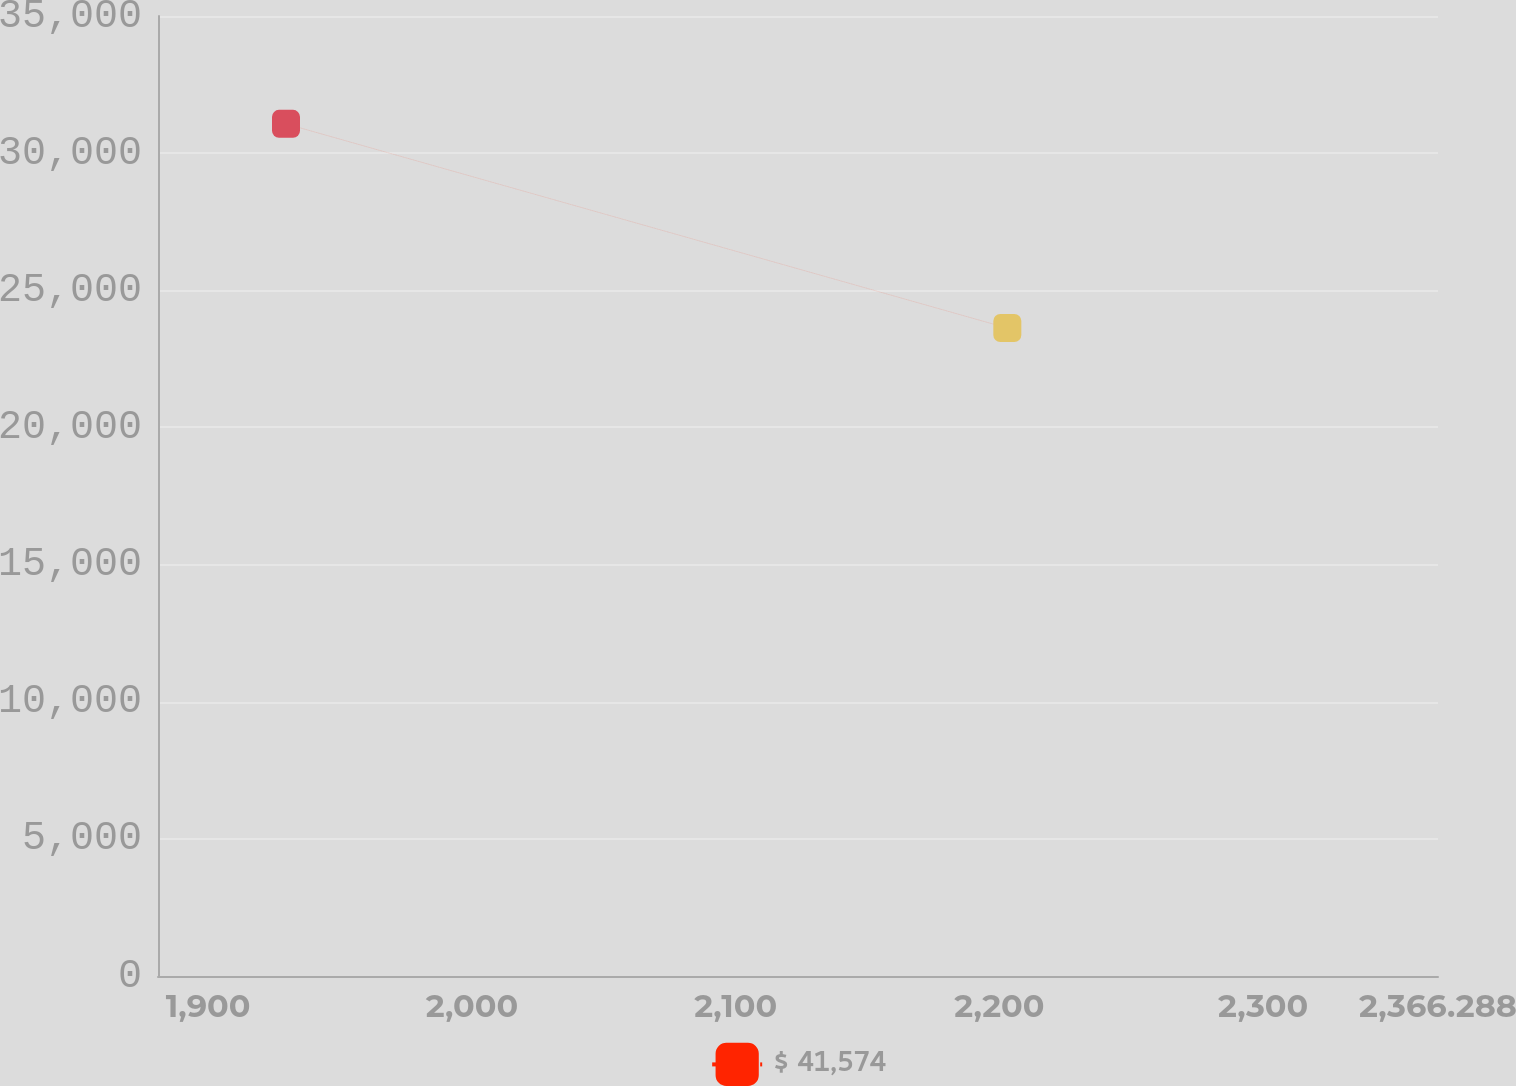Convert chart to OTSL. <chart><loc_0><loc_0><loc_500><loc_500><line_chart><ecel><fcel>$ 41,574<nl><fcel>1929.5<fcel>31067.4<nl><fcel>2203<fcel>23622.8<nl><fcel>2368.33<fcel>16855.2<nl><fcel>2414.82<fcel>18276.4<nl></chart> 